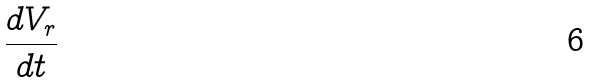Convert formula to latex. <formula><loc_0><loc_0><loc_500><loc_500>\frac { d V _ { r } } { d t }</formula> 